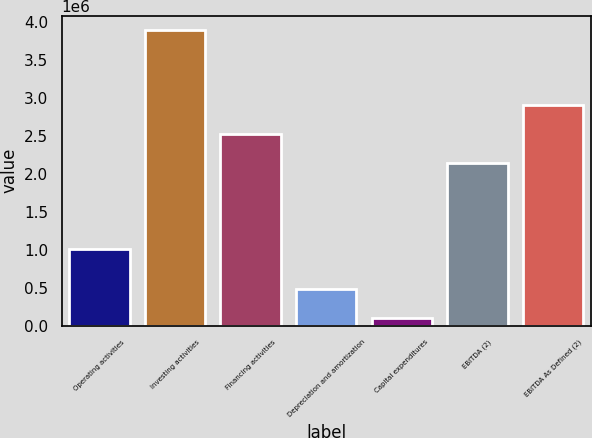<chart> <loc_0><loc_0><loc_500><loc_500><bar_chart><fcel>Operating activities<fcel>Investing activities<fcel>Financing activities<fcel>Depreciation and amortization<fcel>Capital expenditures<fcel>EBITDA (2)<fcel>EBITDA As Defined (2)<nl><fcel>1.01547e+06<fcel>3.88898e+06<fcel>2.52706e+06<fcel>480330<fcel>101591<fcel>2.14832e+06<fcel>2.9058e+06<nl></chart> 